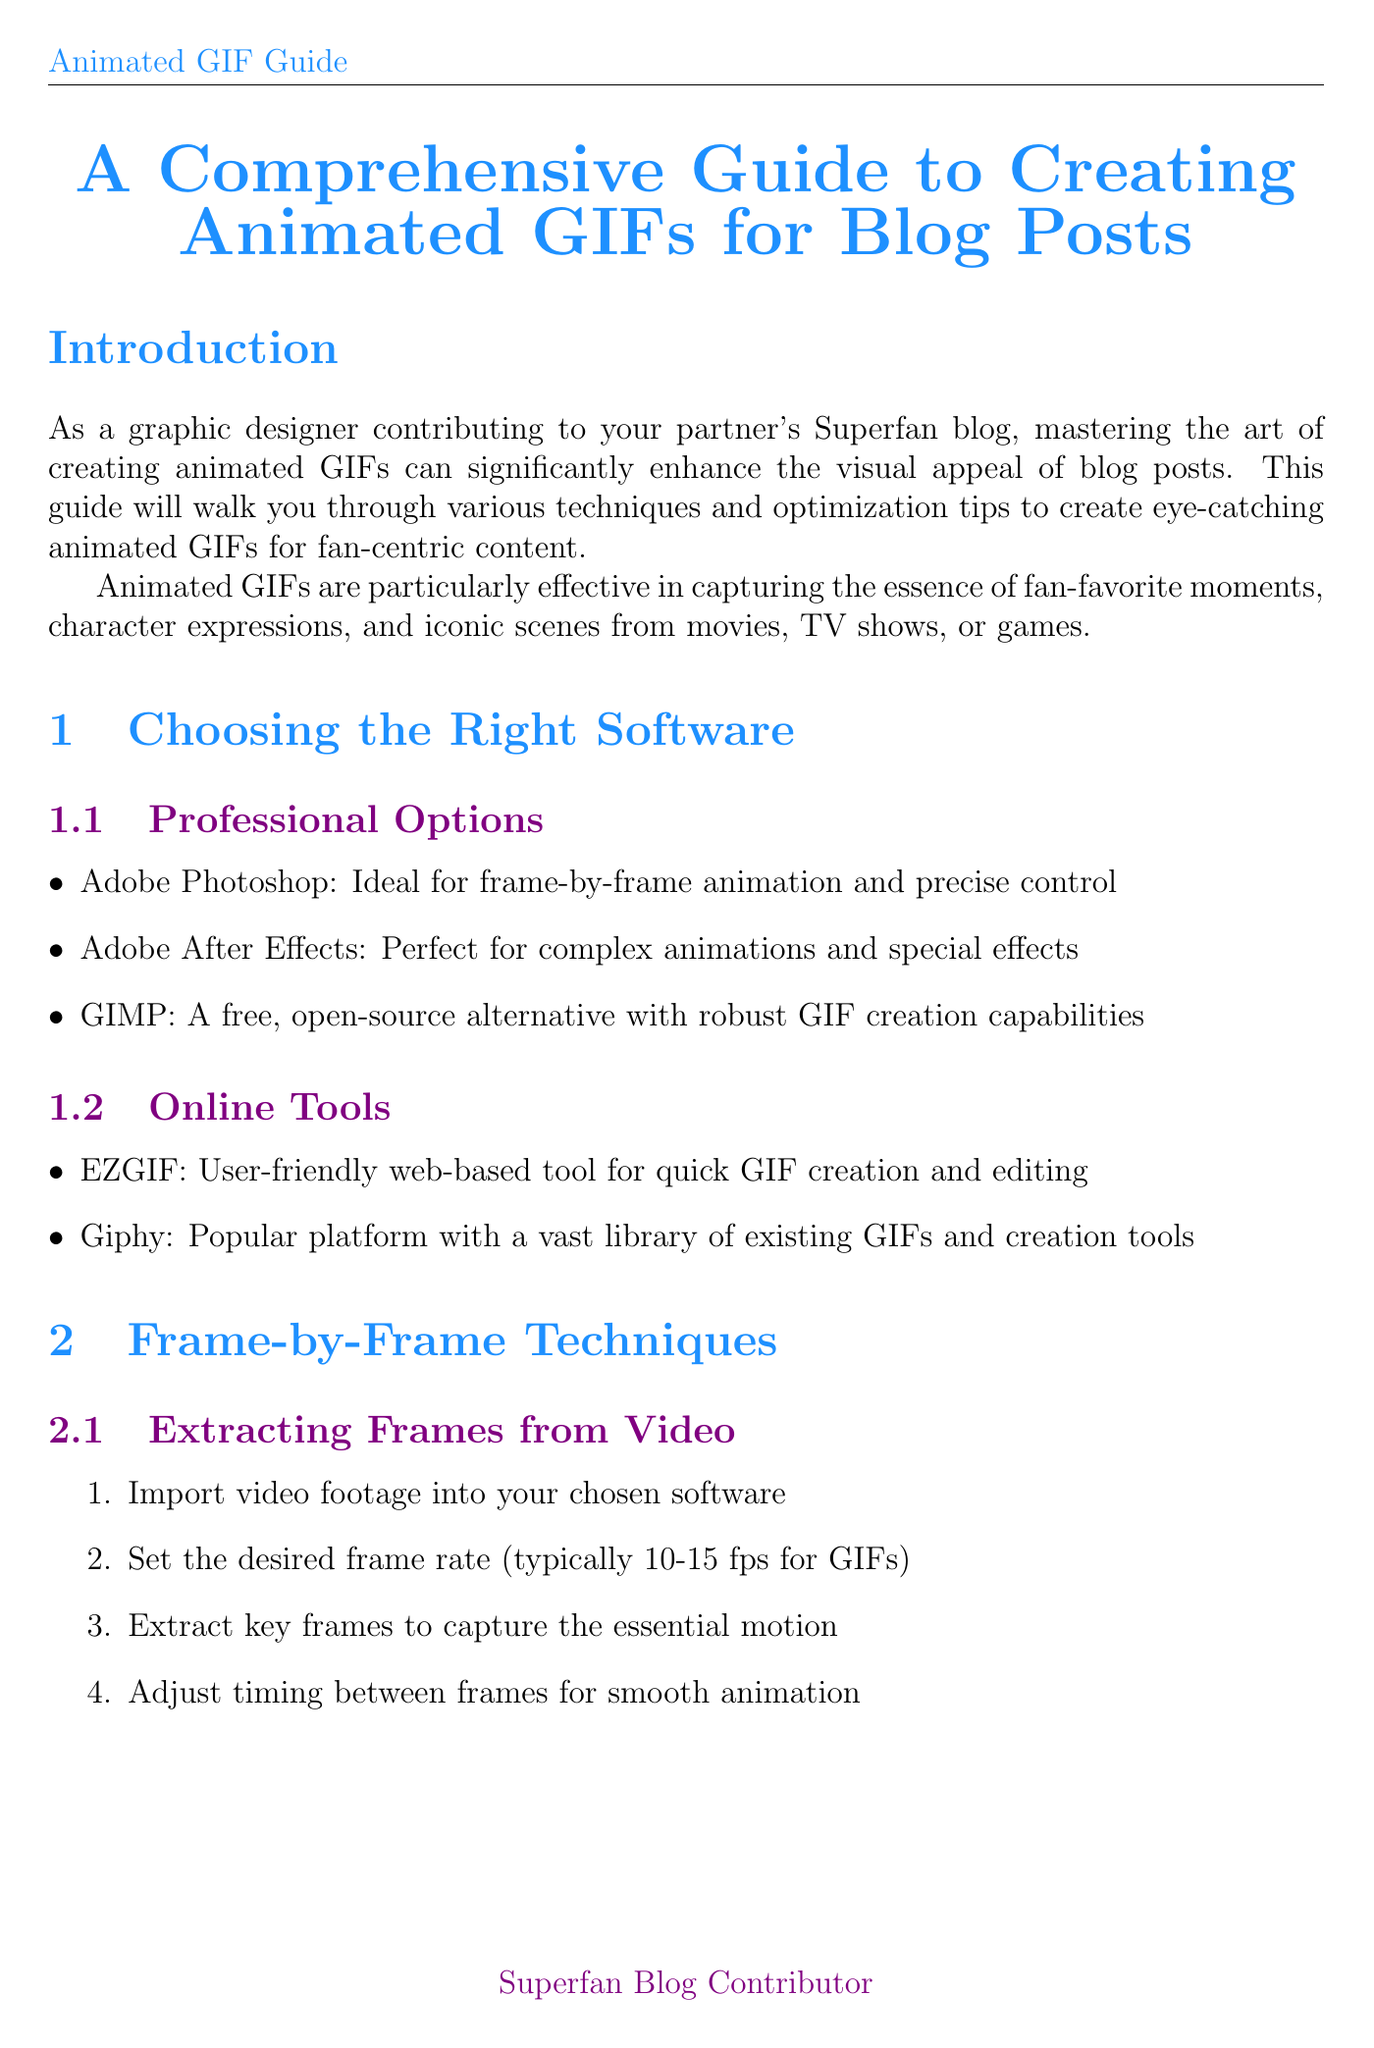What is the title of the guide? The title is mentioned in the introduction as the main subject of the document.
Answer: A Comprehensive Guide to Creating Animated GIFs for Blog Posts What software is ideal for frame-by-frame animation? The document lists software options in the "Choosing the Right Software" chapter, specifying their best uses.
Answer: Adobe Photoshop How many fps is typically set for GIFs? The document provides specific frame rates for creating animated GIFs in the "Extracting Frames from Video" section.
Answer: 10-15 fps What is one optimization tip to reduce file size? The "File Size Reduction" section lists various tips for optimization, focusing on reducing GIF file size.
Answer: Limit color palette to 256 colors or less Name one fandom mentioned in the guide for creating GIFs. The guide features several fandoms under the "Creating GIFs for Specific Fandoms" chapter.
Answer: Marvel Cinematic Universe What is the recommended dimension for a new document in hand-drawn animation? The "Hand-Drawn Animation" section specifies dimensions for creating GIF animations.
Answer: 500x500 pixels What is one best practice for integrating GIFs into blog posts? The "Best Practices" subsection provides several guidelines for using GIFs effectively within blog content.
Answer: Use GIFs sparingly to avoid overwhelming readers What is one creative application of GIFs suggested in the guide? The document lists various creative uses for GIFs in the "Creative Applications" section, showcasing their usefulness in fan-centric content.
Answer: Create reaction GIFs for fan theories or plot twists 